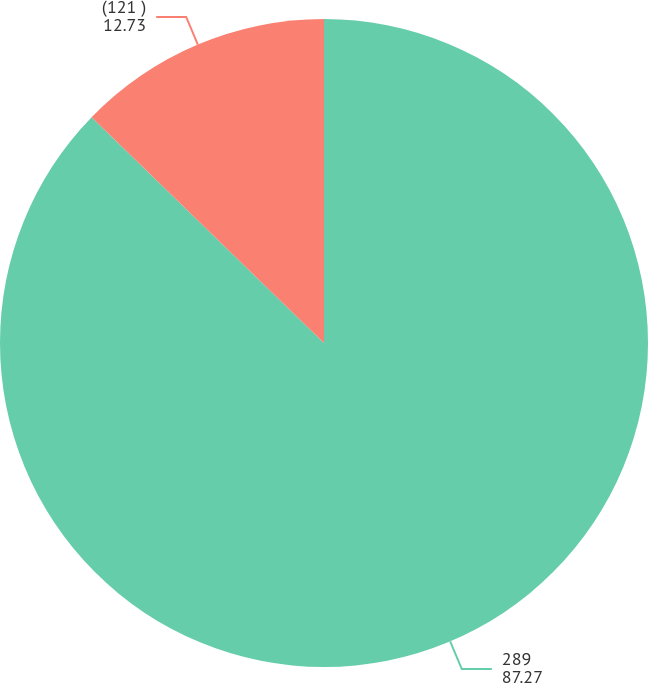Convert chart to OTSL. <chart><loc_0><loc_0><loc_500><loc_500><pie_chart><fcel>289<fcel>(121 )<nl><fcel>87.27%<fcel>12.73%<nl></chart> 